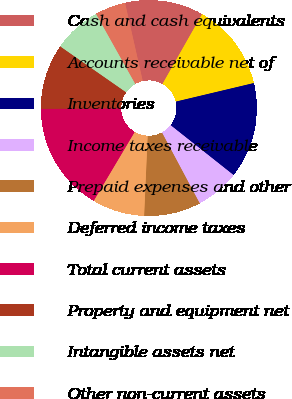Convert chart to OTSL. <chart><loc_0><loc_0><loc_500><loc_500><pie_chart><fcel>Cash and cash equivalents<fcel>Accounts receivable net of<fcel>Inventories<fcel>Income taxes receivable<fcel>Prepaid expenses and other<fcel>Deferred income taxes<fcel>Total current assets<fcel>Property and equipment net<fcel>Intangible assets net<fcel>Other non-current assets<nl><fcel>11.76%<fcel>13.07%<fcel>14.38%<fcel>6.54%<fcel>8.5%<fcel>7.84%<fcel>16.34%<fcel>9.8%<fcel>7.19%<fcel>4.58%<nl></chart> 